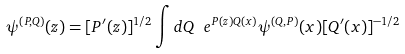Convert formula to latex. <formula><loc_0><loc_0><loc_500><loc_500>\psi ^ { ( P , Q ) } ( z ) = [ P ^ { \prime } ( z ) ] ^ { 1 / 2 } \int d Q \ e ^ { P ( z ) Q ( x ) } \psi ^ { ( Q , P ) } ( x ) [ Q ^ { \prime } ( x ) ] ^ { - 1 / 2 }</formula> 